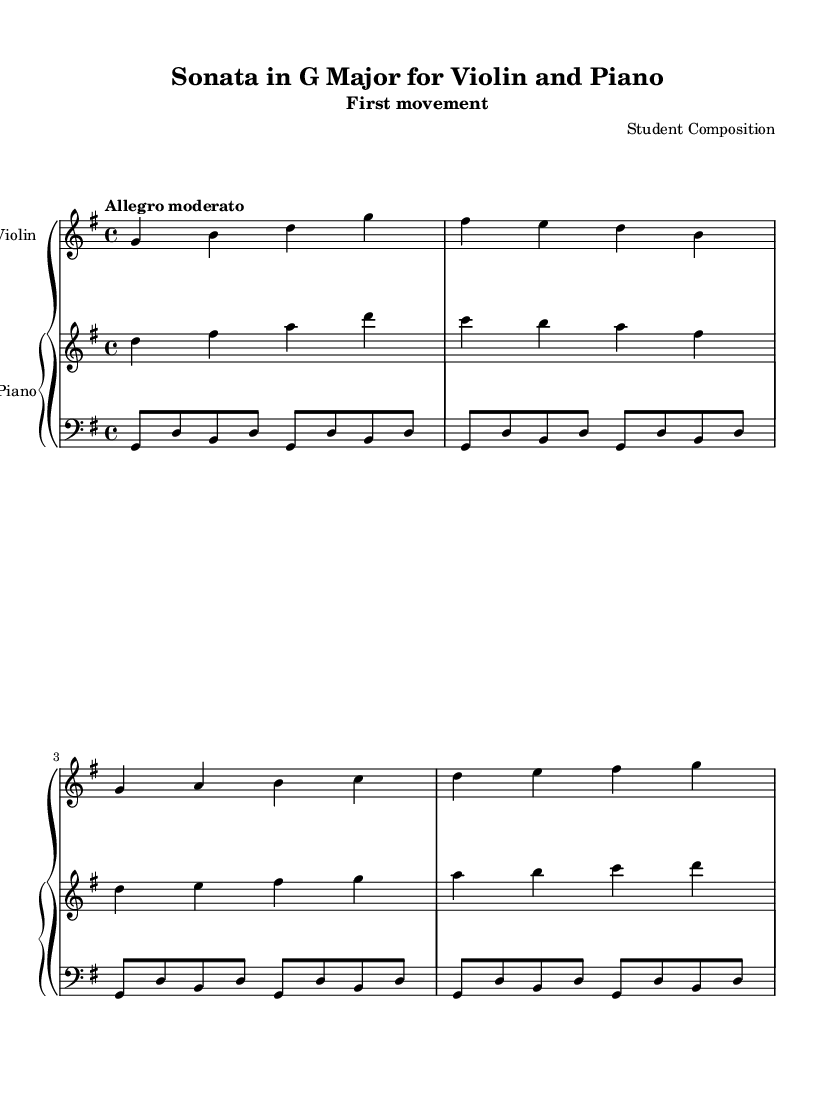What is the key signature of this music? The key signature is G major, which has one sharp (F#). You can identify it at the beginning of the staff, where the F note shows a sharp symbol.
Answer: G major What is the time signature of this piece? The time signature is 4/4, indicated at the beginning of the music. In 4/4, there are four beats per measure, with each quarter note receiving one beat.
Answer: 4/4 What is the tempo marking for this movement? The tempo marking indicates "Allegro moderato," which suggests a moderately fast tempo. It's found near the start of the music, showing the intended speed for performance.
Answer: Allegro moderato How many measures are present in the violin part? The violin part contains four measures. You can count them by identifying the vertical bar lines that separate each measure in the staff.
Answer: 4 What is the primary texture of the ensemble in this piece? The primary texture is homophonic because the violin melody is supported by the harmonic accompaniment of the piano. The violin carries the main melodic line while the piano complements it.
Answer: Homophonic In which movement is this sonata found? This is the first movement of the sonata. The title specifies "First movement" just below the title, indicating its position in the overall structure of the sonata.
Answer: First movement 